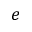<formula> <loc_0><loc_0><loc_500><loc_500>e</formula> 